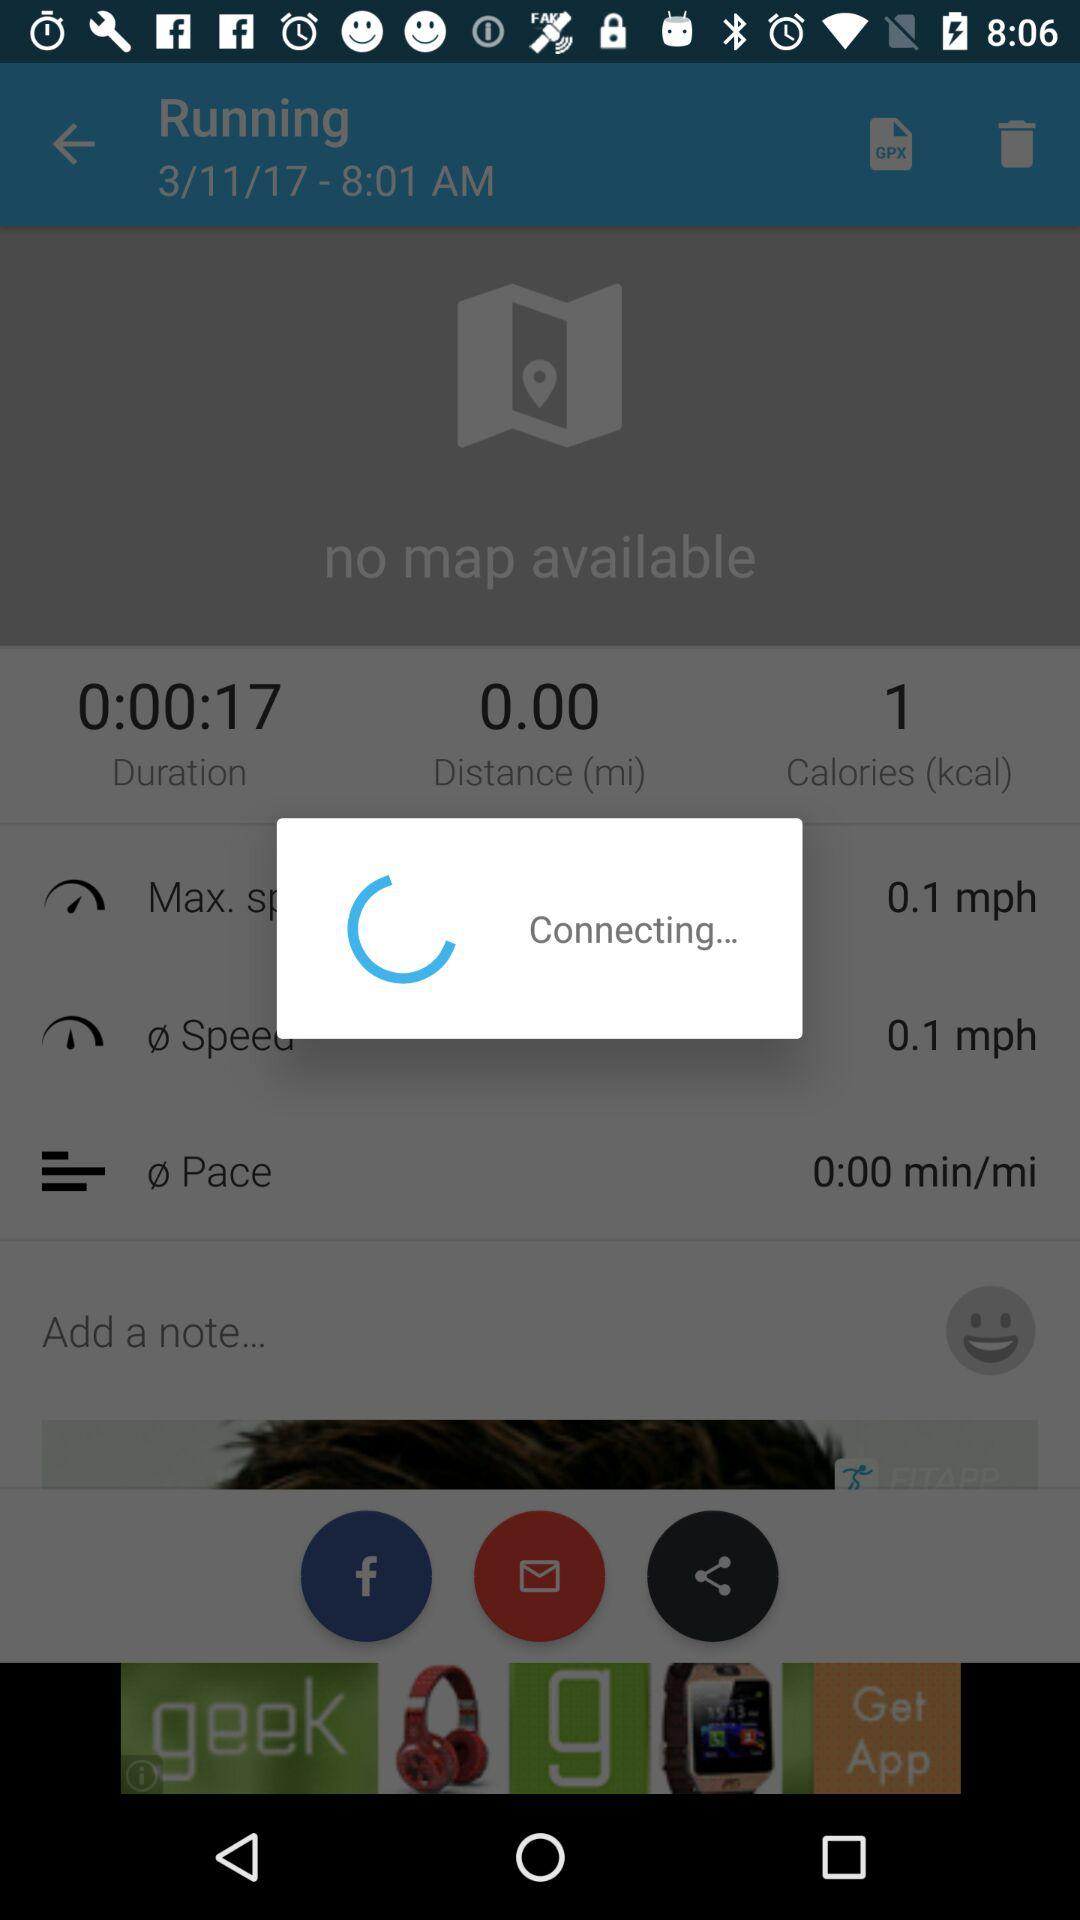What is the duration?
When the provided information is insufficient, respond with <no answer>. <no answer> 